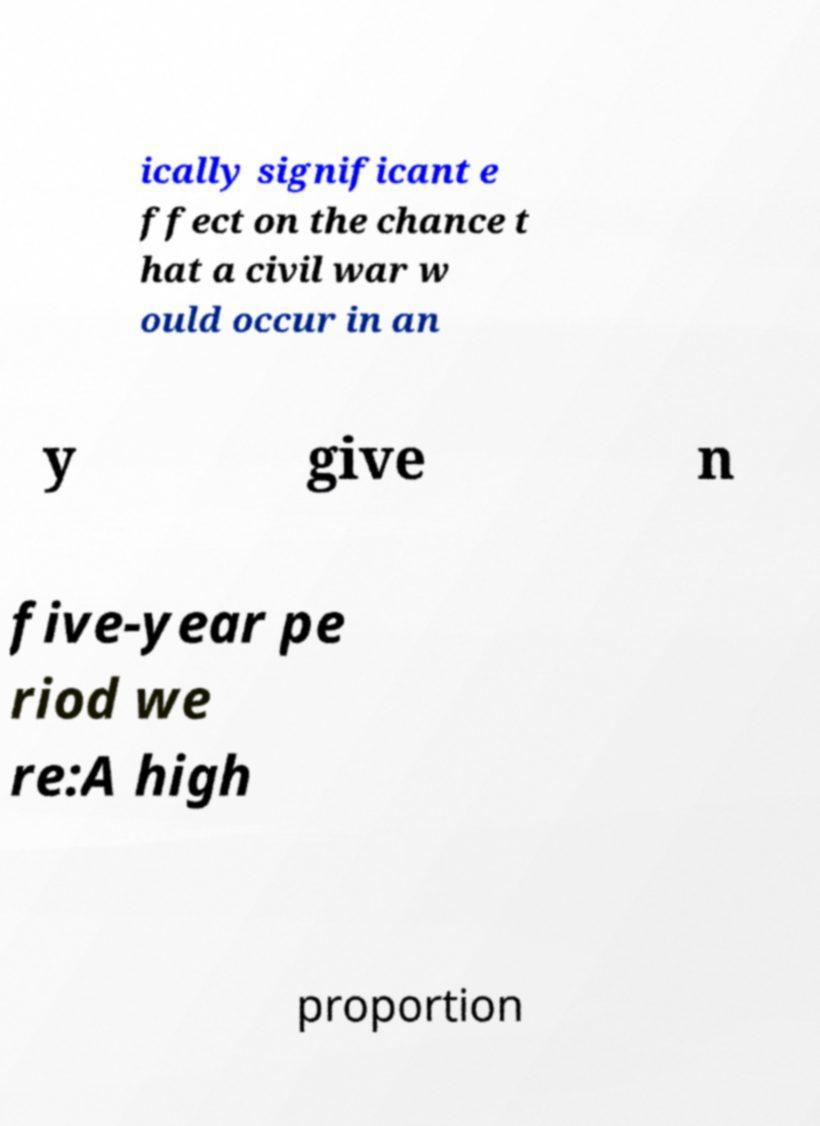What messages or text are displayed in this image? I need them in a readable, typed format. ically significant e ffect on the chance t hat a civil war w ould occur in an y give n five-year pe riod we re:A high proportion 